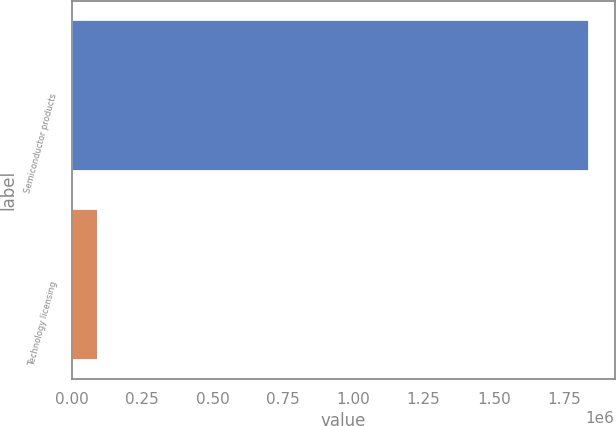Convert chart. <chart><loc_0><loc_0><loc_500><loc_500><bar_chart><fcel>Semiconductor products<fcel>Technology licensing<nl><fcel>1.83664e+06<fcel>94578<nl></chart> 